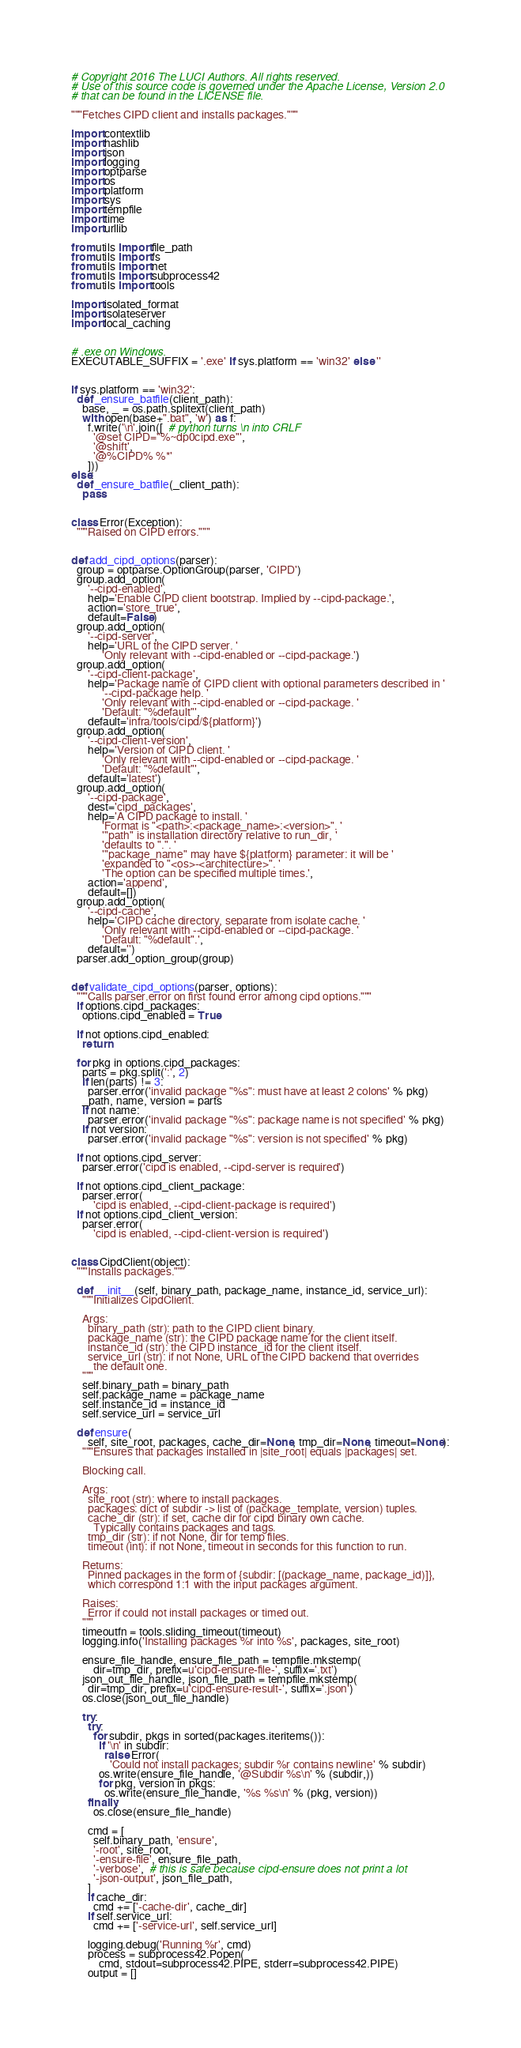Convert code to text. <code><loc_0><loc_0><loc_500><loc_500><_Python_># Copyright 2016 The LUCI Authors. All rights reserved.
# Use of this source code is governed under the Apache License, Version 2.0
# that can be found in the LICENSE file.

"""Fetches CIPD client and installs packages."""

import contextlib
import hashlib
import json
import logging
import optparse
import os
import platform
import sys
import tempfile
import time
import urllib

from utils import file_path
from utils import fs
from utils import net
from utils import subprocess42
from utils import tools

import isolated_format
import isolateserver
import local_caching


# .exe on Windows.
EXECUTABLE_SUFFIX = '.exe' if sys.platform == 'win32' else ''


if sys.platform == 'win32':
  def _ensure_batfile(client_path):
    base, _ = os.path.splitext(client_path)
    with open(base+".bat", 'w') as f:
      f.write('\n'.join([  # python turns \n into CRLF
        '@set CIPD="%~dp0cipd.exe"',
        '@shift',
        '@%CIPD% %*'
      ]))
else:
  def _ensure_batfile(_client_path):
    pass


class Error(Exception):
  """Raised on CIPD errors."""


def add_cipd_options(parser):
  group = optparse.OptionGroup(parser, 'CIPD')
  group.add_option(
      '--cipd-enabled',
      help='Enable CIPD client bootstrap. Implied by --cipd-package.',
      action='store_true',
      default=False)
  group.add_option(
      '--cipd-server',
      help='URL of the CIPD server. '
           'Only relevant with --cipd-enabled or --cipd-package.')
  group.add_option(
      '--cipd-client-package',
      help='Package name of CIPD client with optional parameters described in '
           '--cipd-package help. '
           'Only relevant with --cipd-enabled or --cipd-package. '
           'Default: "%default"',
      default='infra/tools/cipd/${platform}')
  group.add_option(
      '--cipd-client-version',
      help='Version of CIPD client. '
           'Only relevant with --cipd-enabled or --cipd-package. '
           'Default: "%default"',
      default='latest')
  group.add_option(
      '--cipd-package',
      dest='cipd_packages',
      help='A CIPD package to install. '
           'Format is "<path>:<package_name>:<version>". '
           '"path" is installation directory relative to run_dir, '
           'defaults to ".". '
           '"package_name" may have ${platform} parameter: it will be '
           'expanded to "<os>-<architecture>". '
           'The option can be specified multiple times.',
      action='append',
      default=[])
  group.add_option(
      '--cipd-cache',
      help='CIPD cache directory, separate from isolate cache. '
           'Only relevant with --cipd-enabled or --cipd-package. '
           'Default: "%default".',
      default='')
  parser.add_option_group(group)


def validate_cipd_options(parser, options):
  """Calls parser.error on first found error among cipd options."""
  if options.cipd_packages:
    options.cipd_enabled = True

  if not options.cipd_enabled:
    return

  for pkg in options.cipd_packages:
    parts = pkg.split(':', 2)
    if len(parts) != 3:
      parser.error('invalid package "%s": must have at least 2 colons' % pkg)
    _path, name, version = parts
    if not name:
      parser.error('invalid package "%s": package name is not specified' % pkg)
    if not version:
      parser.error('invalid package "%s": version is not specified' % pkg)

  if not options.cipd_server:
    parser.error('cipd is enabled, --cipd-server is required')

  if not options.cipd_client_package:
    parser.error(
        'cipd is enabled, --cipd-client-package is required')
  if not options.cipd_client_version:
    parser.error(
        'cipd is enabled, --cipd-client-version is required')


class CipdClient(object):
  """Installs packages."""

  def __init__(self, binary_path, package_name, instance_id, service_url):
    """Initializes CipdClient.

    Args:
      binary_path (str): path to the CIPD client binary.
      package_name (str): the CIPD package name for the client itself.
      instance_id (str): the CIPD instance_id for the client itself.
      service_url (str): if not None, URL of the CIPD backend that overrides
        the default one.
    """
    self.binary_path = binary_path
    self.package_name = package_name
    self.instance_id = instance_id
    self.service_url = service_url

  def ensure(
      self, site_root, packages, cache_dir=None, tmp_dir=None, timeout=None):
    """Ensures that packages installed in |site_root| equals |packages| set.

    Blocking call.

    Args:
      site_root (str): where to install packages.
      packages: dict of subdir -> list of (package_template, version) tuples.
      cache_dir (str): if set, cache dir for cipd binary own cache.
        Typically contains packages and tags.
      tmp_dir (str): if not None, dir for temp files.
      timeout (int): if not None, timeout in seconds for this function to run.

    Returns:
      Pinned packages in the form of {subdir: [(package_name, package_id)]},
      which correspond 1:1 with the input packages argument.

    Raises:
      Error if could not install packages or timed out.
    """
    timeoutfn = tools.sliding_timeout(timeout)
    logging.info('Installing packages %r into %s', packages, site_root)

    ensure_file_handle, ensure_file_path = tempfile.mkstemp(
        dir=tmp_dir, prefix=u'cipd-ensure-file-', suffix='.txt')
    json_out_file_handle, json_file_path = tempfile.mkstemp(
      dir=tmp_dir, prefix=u'cipd-ensure-result-', suffix='.json')
    os.close(json_out_file_handle)

    try:
      try:
        for subdir, pkgs in sorted(packages.iteritems()):
          if '\n' in subdir:
            raise Error(
              'Could not install packages; subdir %r contains newline' % subdir)
          os.write(ensure_file_handle, '@Subdir %s\n' % (subdir,))
          for pkg, version in pkgs:
            os.write(ensure_file_handle, '%s %s\n' % (pkg, version))
      finally:
        os.close(ensure_file_handle)

      cmd = [
        self.binary_path, 'ensure',
        '-root', site_root,
        '-ensure-file', ensure_file_path,
        '-verbose',  # this is safe because cipd-ensure does not print a lot
        '-json-output', json_file_path,
      ]
      if cache_dir:
        cmd += ['-cache-dir', cache_dir]
      if self.service_url:
        cmd += ['-service-url', self.service_url]

      logging.debug('Running %r', cmd)
      process = subprocess42.Popen(
          cmd, stdout=subprocess42.PIPE, stderr=subprocess42.PIPE)
      output = []</code> 